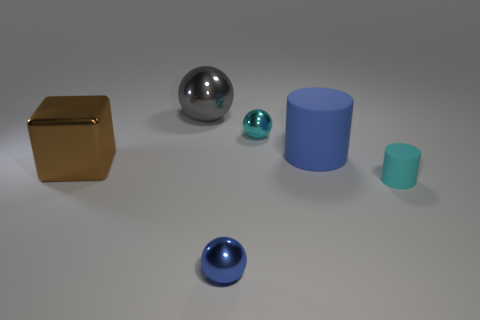There is a tiny object that is the same color as the big cylinder; what is its material?
Keep it short and to the point. Metal. Are there fewer spheres than cyan matte cylinders?
Offer a terse response. No. What is the shape of the cyan rubber thing that is the same size as the blue metal object?
Ensure brevity in your answer.  Cylinder. How many other objects are the same color as the large metallic block?
Provide a succinct answer. 0. How many big gray metallic balls are there?
Make the answer very short. 1. What number of small things are both behind the brown object and in front of the large brown metallic thing?
Provide a short and direct response. 0. What is the material of the block?
Make the answer very short. Metal. Are any small cyan metal spheres visible?
Keep it short and to the point. Yes. The small thing in front of the cyan cylinder is what color?
Your answer should be compact. Blue. How many tiny shiny balls are in front of the cyan object that is to the left of the cylinder behind the small cyan rubber cylinder?
Provide a short and direct response. 1. 